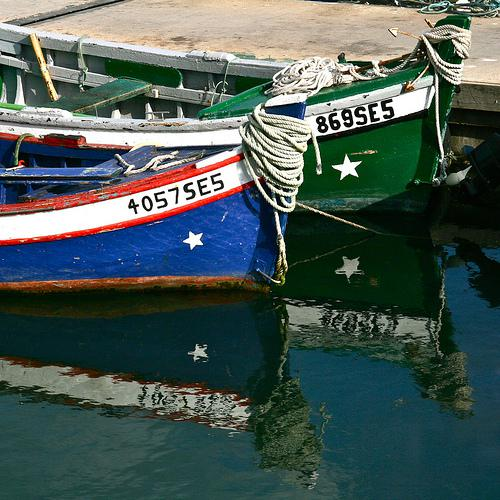Question: what shape is painted on both boats?
Choices:
A. A star.
B. A heart.
C. A diamond.
D. A circle.
Answer with the letter. Answer: A Question: what color is the boat in the back?
Choices:
A. Green.
B. White.
C. Grey.
D. Black.
Answer with the letter. Answer: A Question: when is this?
Choices:
A. Daytime.
B. Lunchtime.
C. Morning.
D. Afternoon.
Answer with the letter. Answer: A Question: why are the boats still?
Choices:
A. No wind.
B. The are tied to the dock.
C. They are anchored.
D. Water is all gone.
Answer with the letter. Answer: B Question: how many boats are there?
Choices:
A. One.
B. Two.
C. Four.
D. Three.
Answer with the letter. Answer: B Question: where are the boats?
Choices:
A. In the lake.
B. In the ocean.
C. In the water.
D. In the pond.
Answer with the letter. Answer: C Question: what numbers and letters are on the boat in the front?
Choices:
A. 4057se5.
B. 205nwb.
C. Rocket12.
D. 18swb.
Answer with the letter. Answer: A Question: what are the boats tied to the dock with?
Choices:
A. Rope.
B. Chains.
C. Cable.
D. Nylon rope.
Answer with the letter. Answer: A 